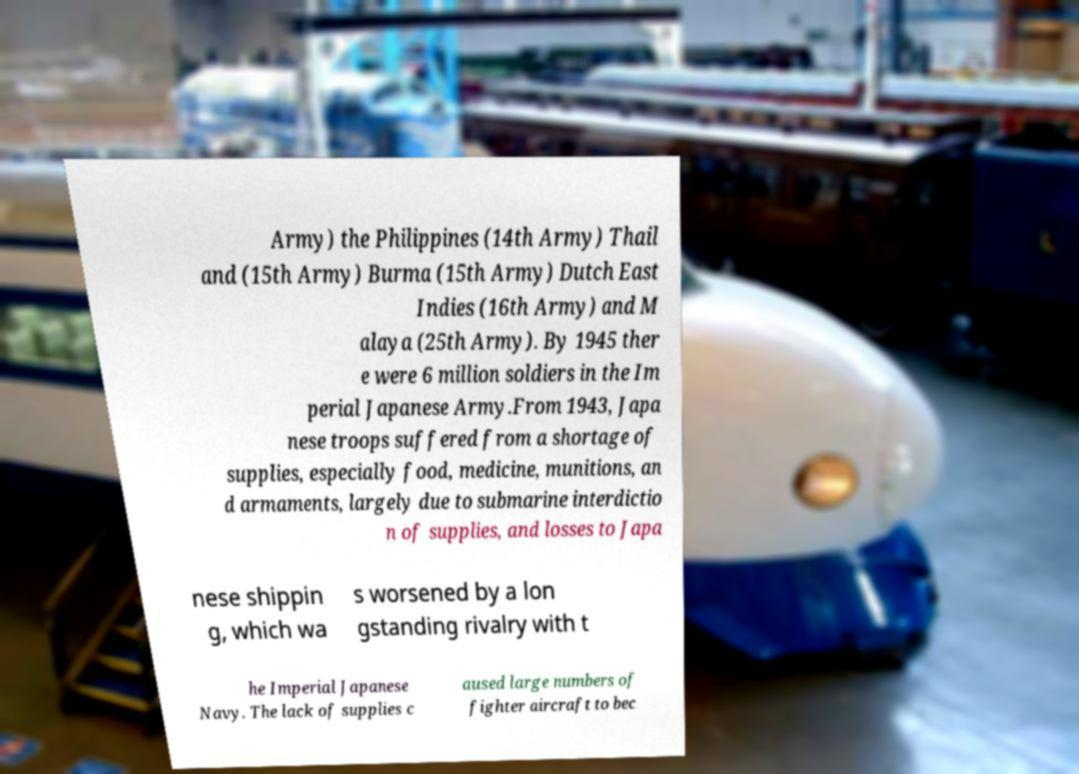Could you assist in decoding the text presented in this image and type it out clearly? Army) the Philippines (14th Army) Thail and (15th Army) Burma (15th Army) Dutch East Indies (16th Army) and M alaya (25th Army). By 1945 ther e were 6 million soldiers in the Im perial Japanese Army.From 1943, Japa nese troops suffered from a shortage of supplies, especially food, medicine, munitions, an d armaments, largely due to submarine interdictio n of supplies, and losses to Japa nese shippin g, which wa s worsened by a lon gstanding rivalry with t he Imperial Japanese Navy. The lack of supplies c aused large numbers of fighter aircraft to bec 